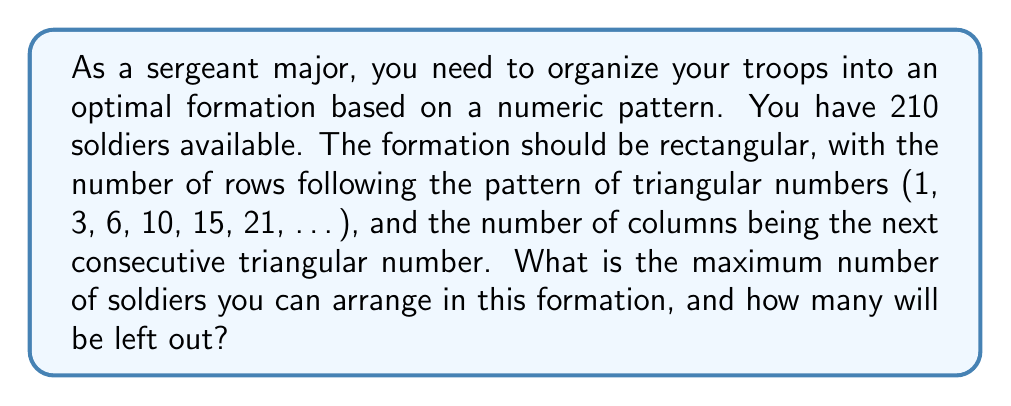Teach me how to tackle this problem. To solve this problem, we need to follow these steps:

1) First, let's recall the formula for triangular numbers:
   $$T_n = \frac{n(n+1)}{2}$$

2) We need to find the largest triangular number that's less than or equal to 210 for the number of rows. Let's calculate:

   $$T_6 = \frac{6(6+1)}{2} = 21$$
   $$T_7 = \frac{7(7+1)}{2} = 28$$

   So, we can have at most 21 rows.

3) The number of columns will be the next triangular number, which is 28.

4) Now, let's calculate the total number of soldiers in this formation:
   $$21 \times 28 = 588$$

5) However, we only have 210 soldiers. So we need to find how many complete rows we can fill:
   $$210 \div 28 = 7.5$$

   This means we can fill 7 complete rows.

6) The number of soldiers in the formation will be:
   $$7 \times 28 = 196$$

7) The number of soldiers left out will be:
   $$210 - 196 = 14$$

Therefore, the maximum number of soldiers in the formation is 196, and 14 will be left out.
Answer: 196 soldiers can be arranged in the formation, with 14 soldiers left out. 